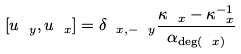Convert formula to latex. <formula><loc_0><loc_0><loc_500><loc_500>[ u _ { \ y } , u _ { \ x } ] = \delta _ { \ x , - \ y } \frac { \kappa _ { \ x } - \kappa ^ { - 1 } _ { \ x } } { \alpha _ { \deg ( \ x ) } }</formula> 